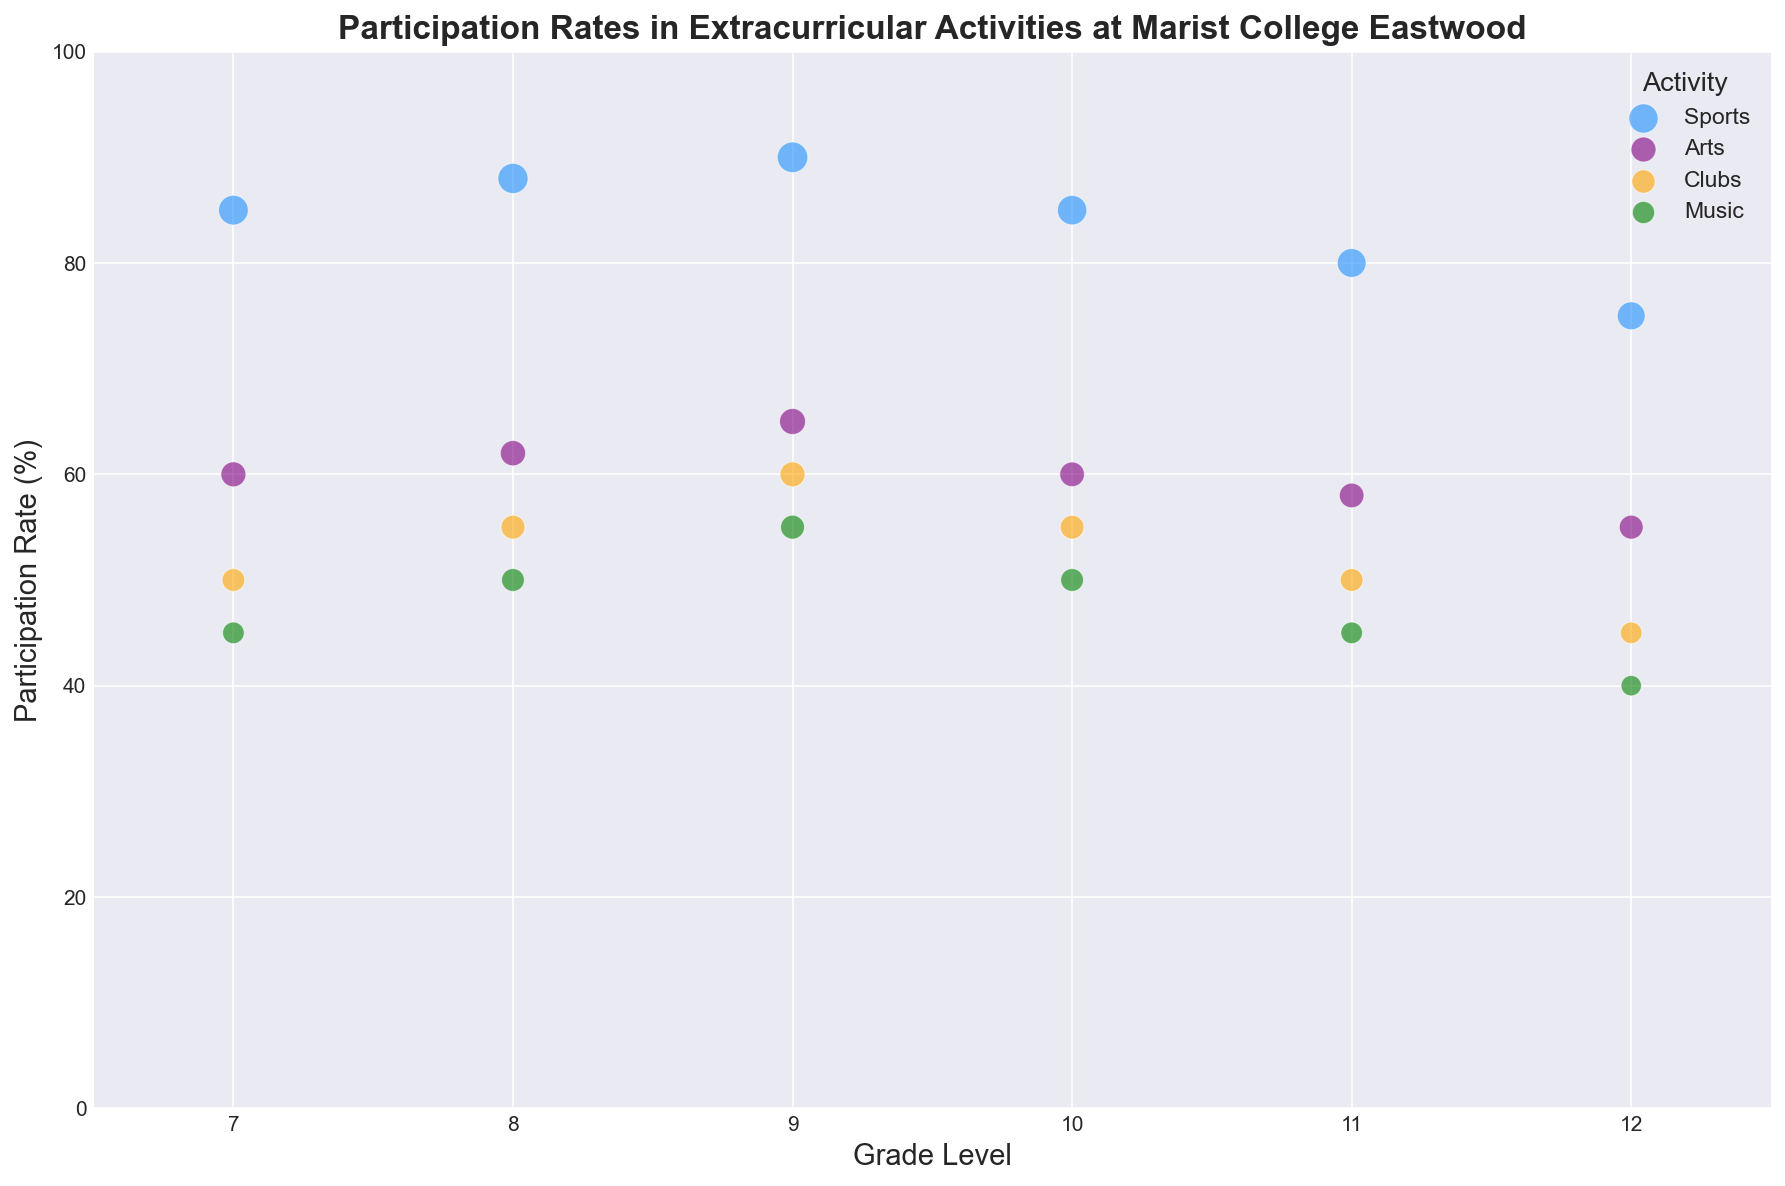Which grade level has the highest participation rate in Sports? First, identify the participation rates for Sports in each grade level. Grade 9 has the highest rate at 90%.
Answer: Grade 9 Which activity has the lowest participation rate for Grade 12? Review all participation rates for Grade 12 activities. Music has the lowest participation rate at 40%.
Answer: Music What is the total number of students participating in Arts across all grades? Sum the number of students participating in Arts for each grade: 72 (Grade 7) + 74 (Grade 8) + 78 (Grade 9) + 70 (Grade 10) + 70 (Grade 11) + 66 (Grade 12) = 430 students.
Answer: 430 Compare the participation rates in Clubs between Grade 7 and Grade 9. Which grade has a higher rate and by how much? Grade 7 has a participation rate of 50% and Grade 9 has 60%. Grade 9's rate is higher by 60% - 50% = 10%.
Answer: Grade 9, 10% Which activity has the largest bubble size for Grade 10? The largest bubble size corresponds to the number of students. For Grade 10, Sports has the largest number of students (100), hence the largest bubble.
Answer: Sports Is the participation rate in Music increasing or decreasing as the grade level rises? Review the participation rates for Music from Grade 7 to 12: 45%, 50%, 55%, 50%, 45%, 40%. It's generally decreasing.
Answer: Decreasing What's the average participation rate for all activities in Grade 8? Sum the participation rates for Grade 8 and divide by the number of activities: (88 + 62 + 55 + 50) / 4 = 63.75%.
Answer: 63.75% Which grade has the highest total number of students participating in activities? Sum the number of students for each grade: Grade 7 (102+72+60+54) = 288, Grade 8 (105+74+66+60) = 305, Grade 9 (108+78+72+66) = 324, Grade 10 (100+70+65+60) = 295, Grade 11 (96+70+60+54) = 280, Grade 12 (90+66+54+48) = 258. Grade 9 has the highest total with 324 students.
Answer: Grade 9 Which activity has the most consistent participation rate across all grades? Review the participation rates for each activity across grades: Sports (85, 88, 90, 85, 80, 75), Arts (60, 62, 65, 60, 58, 55), Clubs (50, 55, 60, 55, 50, 45), Music (45, 50, 55, 50, 45, 40). Clubs has the smallest rate change.
Answer: Clubs 